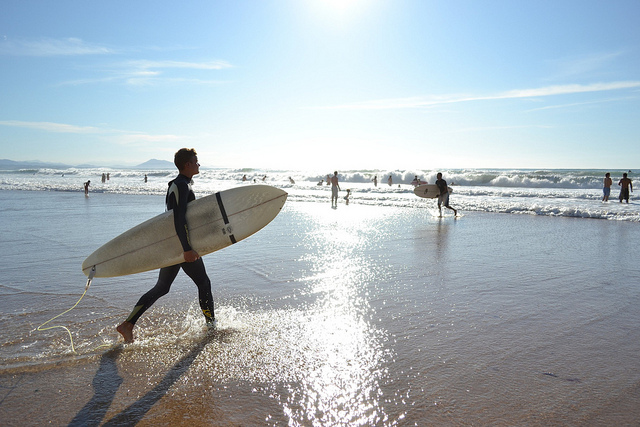What time of day does the image suggest? The image depicts long shadows cast on the sand, indicating that it's either early morning or late afternoon. The sunlight has a warm, golden quality, which often suggests the 'golden hour' typically occurring shortly after sunrise or before sunset.  What might the water temperature be like based on the image? While the exact water temperature cannot be determined from the image alone, the presence of surfers wearing wetsuits suggests that the water might be on the cooler side, prompting the need for thermal insulation. 